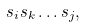Convert formula to latex. <formula><loc_0><loc_0><loc_500><loc_500>s _ { i } s _ { k } \dots s _ { j } ,</formula> 